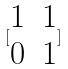Convert formula to latex. <formula><loc_0><loc_0><loc_500><loc_500>[ \begin{matrix} 1 & 1 \\ 0 & 1 \end{matrix} ]</formula> 